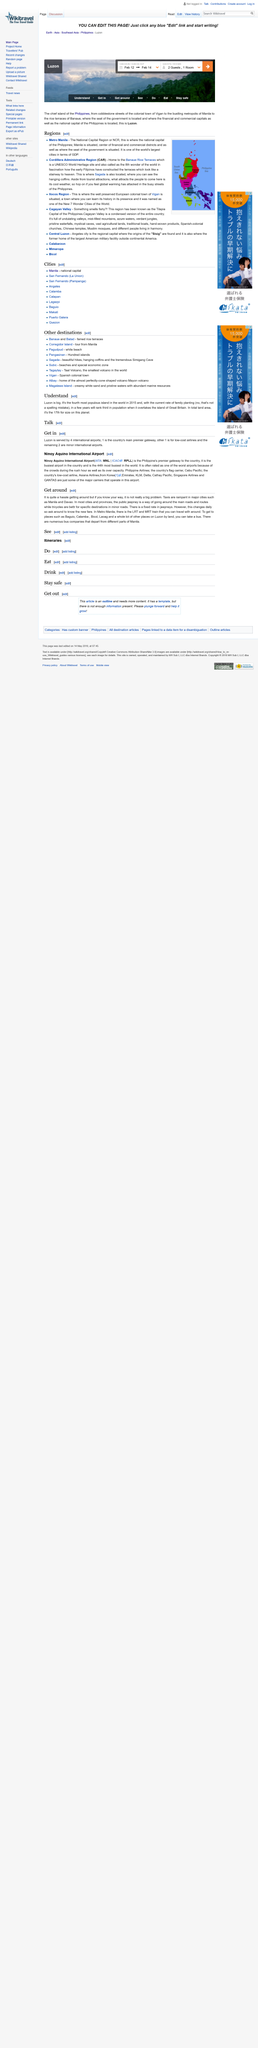Outline some significant characteristics in this image. You are able to check in on February 12th and 14th. The national capital of the Philippines is Manila. The Banaue Rice Terraces, a UNESCO World Heritage Site, are located in the Cordillera Administrative Region. How many guests are depicted in the image? There are a total of two guests shown. The South China Sea borders the Ilocos Region, where Vigan is situated. 